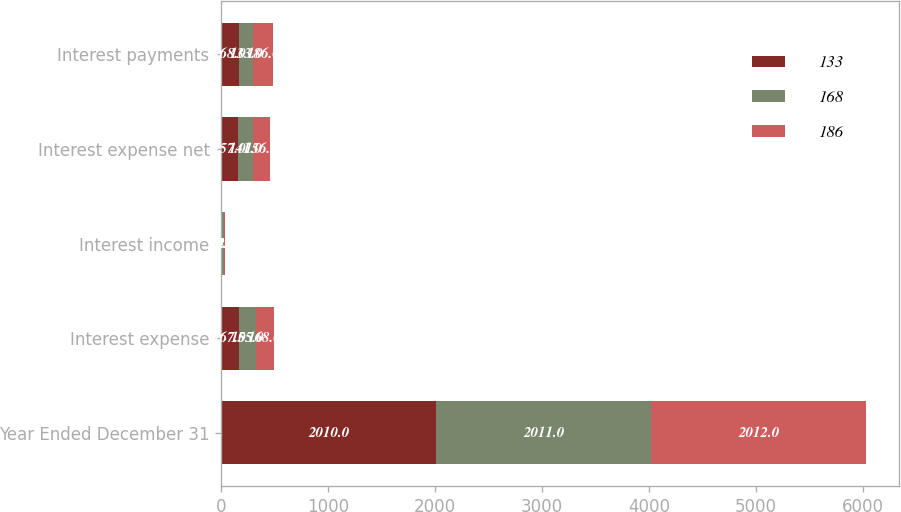<chart> <loc_0><loc_0><loc_500><loc_500><stacked_bar_chart><ecel><fcel>Year Ended December 31<fcel>Interest expense<fcel>Interest income<fcel>Interest expense net<fcel>Interest payments<nl><fcel>133<fcel>2010<fcel>167<fcel>10<fcel>157<fcel>168<nl><fcel>168<fcel>2011<fcel>155<fcel>14<fcel>141<fcel>133<nl><fcel>186<fcel>2012<fcel>168<fcel>12<fcel>156<fcel>186<nl></chart> 